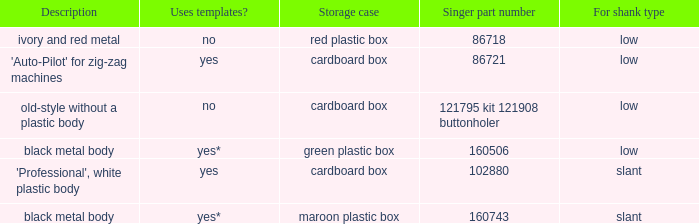What's the description of the buttonholer whose singer part number is 121795 kit 121908 buttonholer? Old-style without a plastic body. 